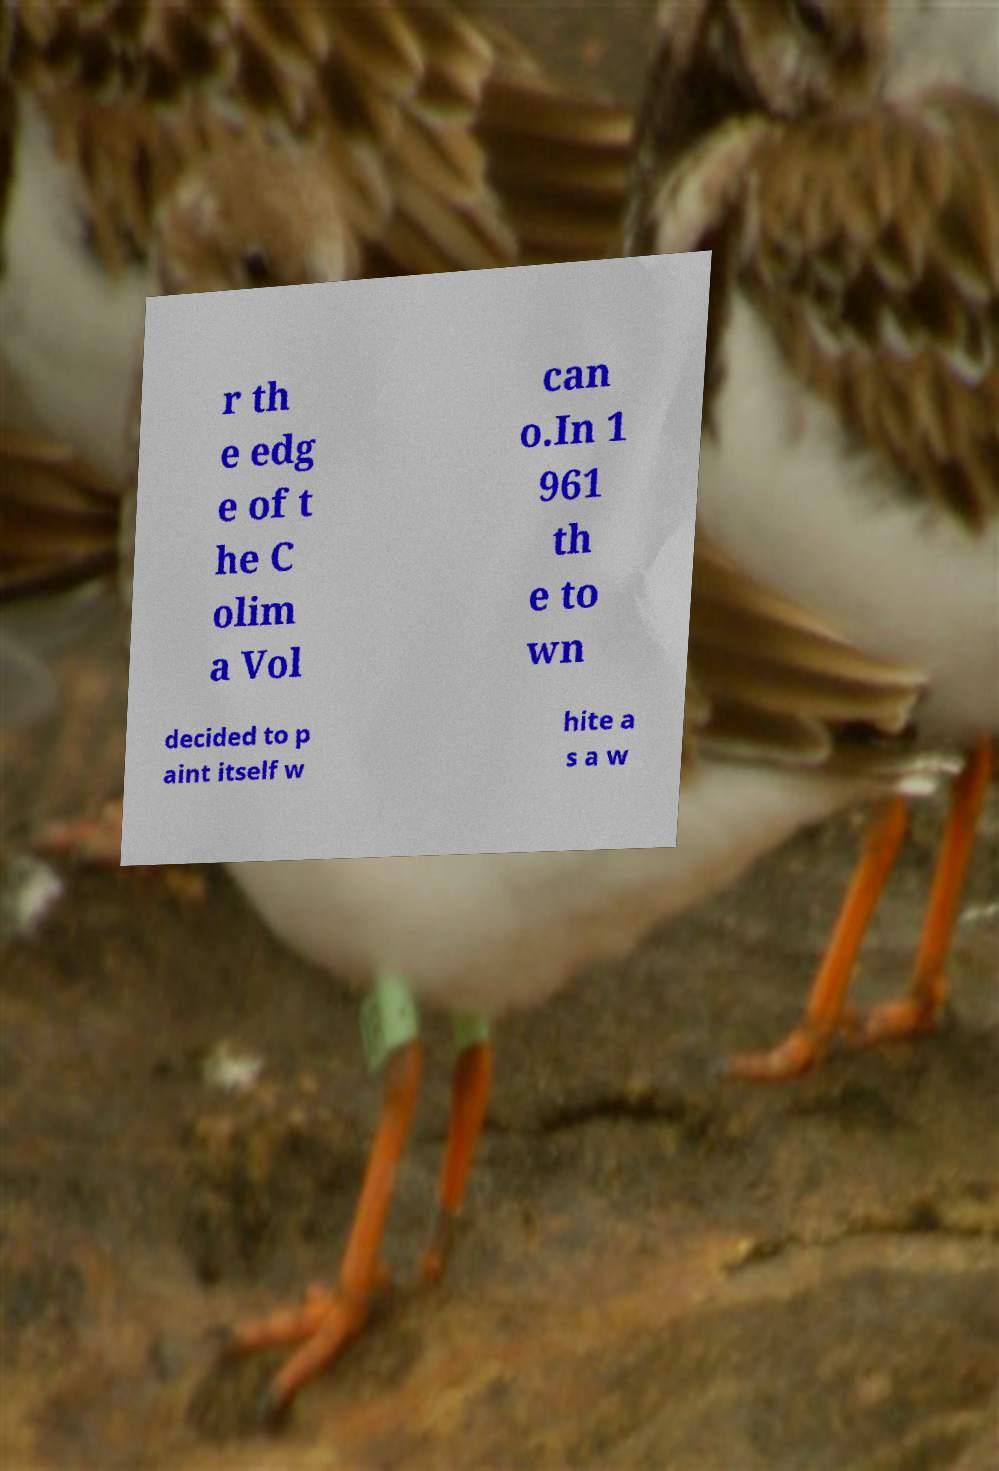Could you assist in decoding the text presented in this image and type it out clearly? r th e edg e of t he C olim a Vol can o.In 1 961 th e to wn decided to p aint itself w hite a s a w 